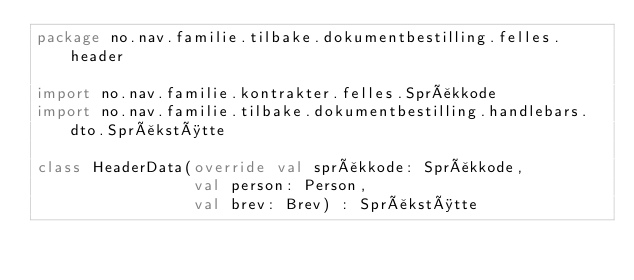Convert code to text. <code><loc_0><loc_0><loc_500><loc_500><_Kotlin_>package no.nav.familie.tilbake.dokumentbestilling.felles.header

import no.nav.familie.kontrakter.felles.Språkkode
import no.nav.familie.tilbake.dokumentbestilling.handlebars.dto.Språkstøtte

class HeaderData(override val språkkode: Språkkode,
                 val person: Person,
                 val brev: Brev) : Språkstøtte

</code> 